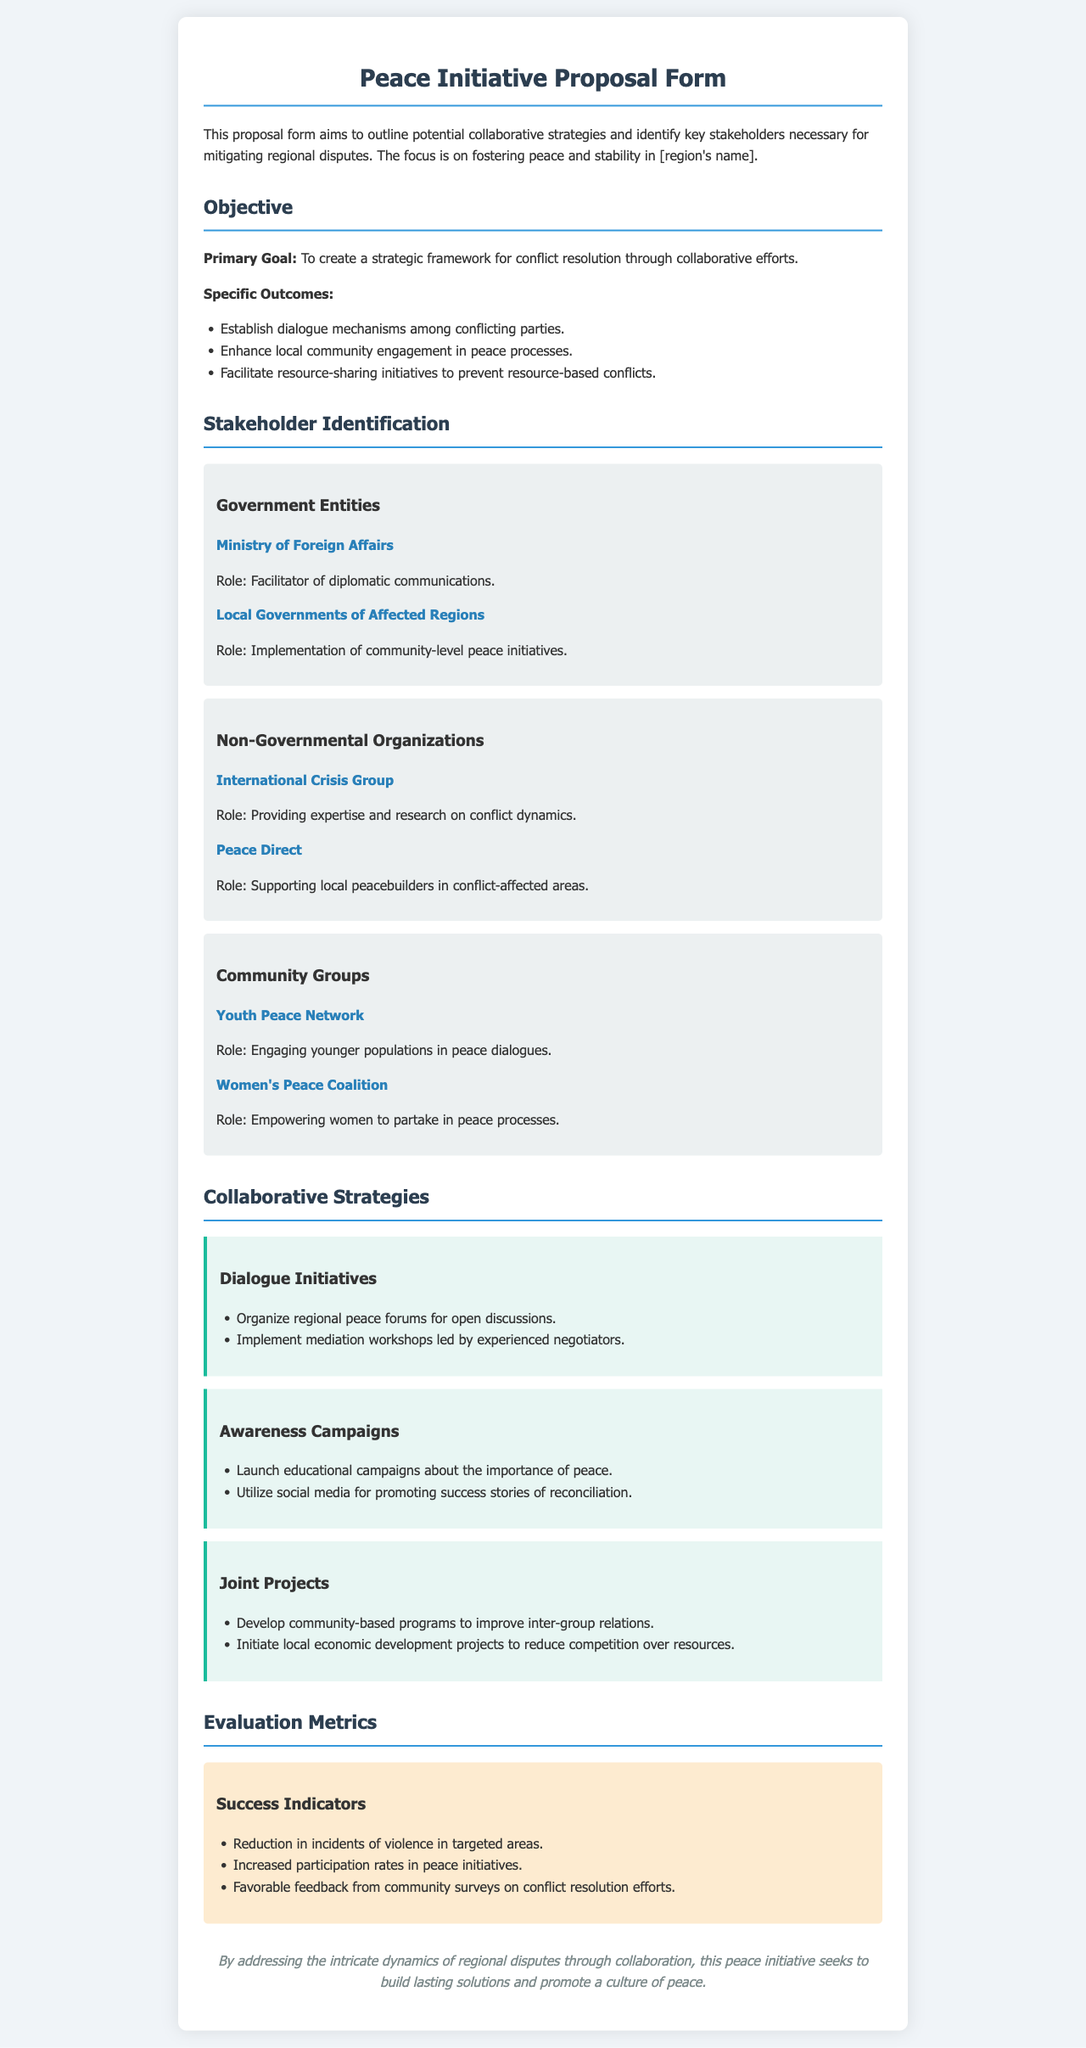what is the primary goal of the initiative? The primary goal is to create a strategic framework for conflict resolution through collaborative efforts.
Answer: strategic framework for conflict resolution which organization supports local peacebuilders? The organization that supports local peacebuilders is mentioned in the document under Non-Governmental Organizations.
Answer: Peace Direct how many community groups are listed? The number of community groups mentioned in the stakeholder identification section is a count of those listed.
Answer: two what is one specific outcome aimed at dialogue mechanisms? The specific outcome related to dialogue mechanisms outlines how conflicting parties engage.
Answer: Establish dialogue mechanisms among conflicting parties name one of the success indicators for evaluation metrics. The success indicators section highlights various metrics, one of which can be specifically stated.
Answer: Reduction in incidents of violence in targeted areas who is responsible for promoting educational campaigns about peace? The responsibility for launching educational campaigns is shared among stakeholders described in the collaborative strategies section.
Answer: Not specified (implied collaboration) what are the two listed types of collaborative strategies? The collaborative strategies section includes various types of initiatives that can be identified by their main focus areas.
Answer: Dialogue Initiatives, Awareness Campaigns which ministry is involved as a government entity? The government entity mentioned is responsible for diplomatic communications and can be directly cited from the document.
Answer: Ministry of Foreign Affairs 